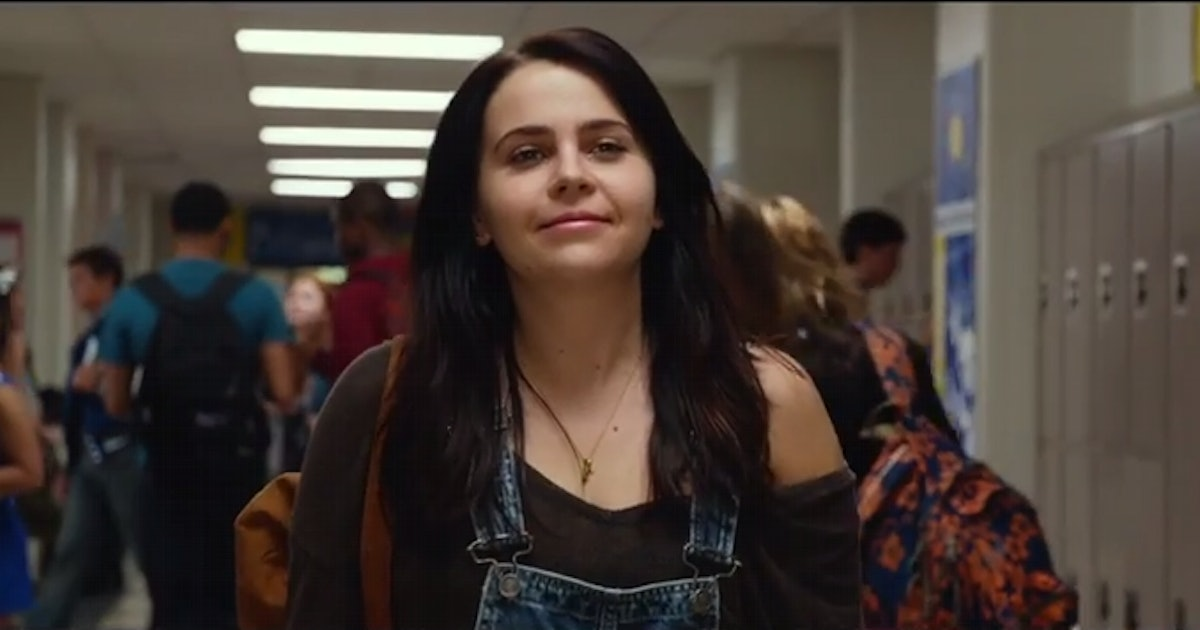What's the mood of this scene? The mood of this scene appears to be casual and energetic. The central character seems relaxed and confident, walking through a crowded high school hallway with a slight smile on her face. The movement of other students around her adds a lively and dynamic atmosphere, typical of a bustling school environment. 